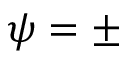<formula> <loc_0><loc_0><loc_500><loc_500>\psi = \pm</formula> 